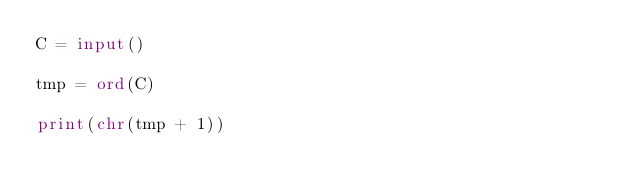<code> <loc_0><loc_0><loc_500><loc_500><_Python_>C = input()

tmp = ord(C)

print(chr(tmp + 1))
</code> 